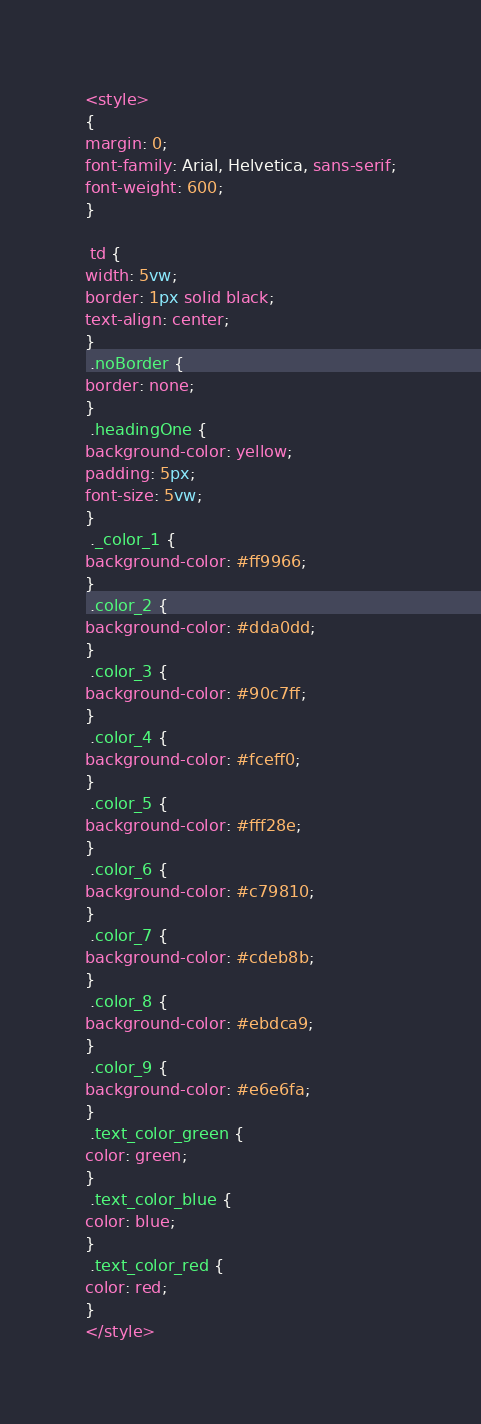Convert code to text. <code><loc_0><loc_0><loc_500><loc_500><_CSS_><style>
{
margin: 0;
font-family: Arial, Helvetica, sans-serif;
font-weight: 600;
}

 td {
width: 5vw;
border: 1px solid black;
text-align: center;
}
 .noBorder {
border: none;
}
 .headingOne {
background-color: yellow;
padding: 5px;
font-size: 5vw;
}
 ._color_1 {
background-color: #ff9966;
}
 .color_2 {
background-color: #dda0dd;
}
 .color_3 {
background-color: #90c7ff;
}
 .color_4 {
background-color: #fceff0;
}
 .color_5 {
background-color: #fff28e;
}
 .color_6 {
background-color: #c79810;
}
 .color_7 {
background-color: #cdeb8b;
}
 .color_8 {
background-color: #ebdca9;
}
 .color_9 {
background-color: #e6e6fa;
}
 .text_color_green {
color: green;
}
 .text_color_blue {
color: blue;
}
 .text_color_red {
color: red;
}
</style></code> 